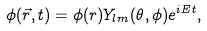<formula> <loc_0><loc_0><loc_500><loc_500>\phi ( \vec { r } , t ) = \phi ( r ) Y _ { l m } ( \theta , \phi ) e ^ { i E t } ,</formula> 